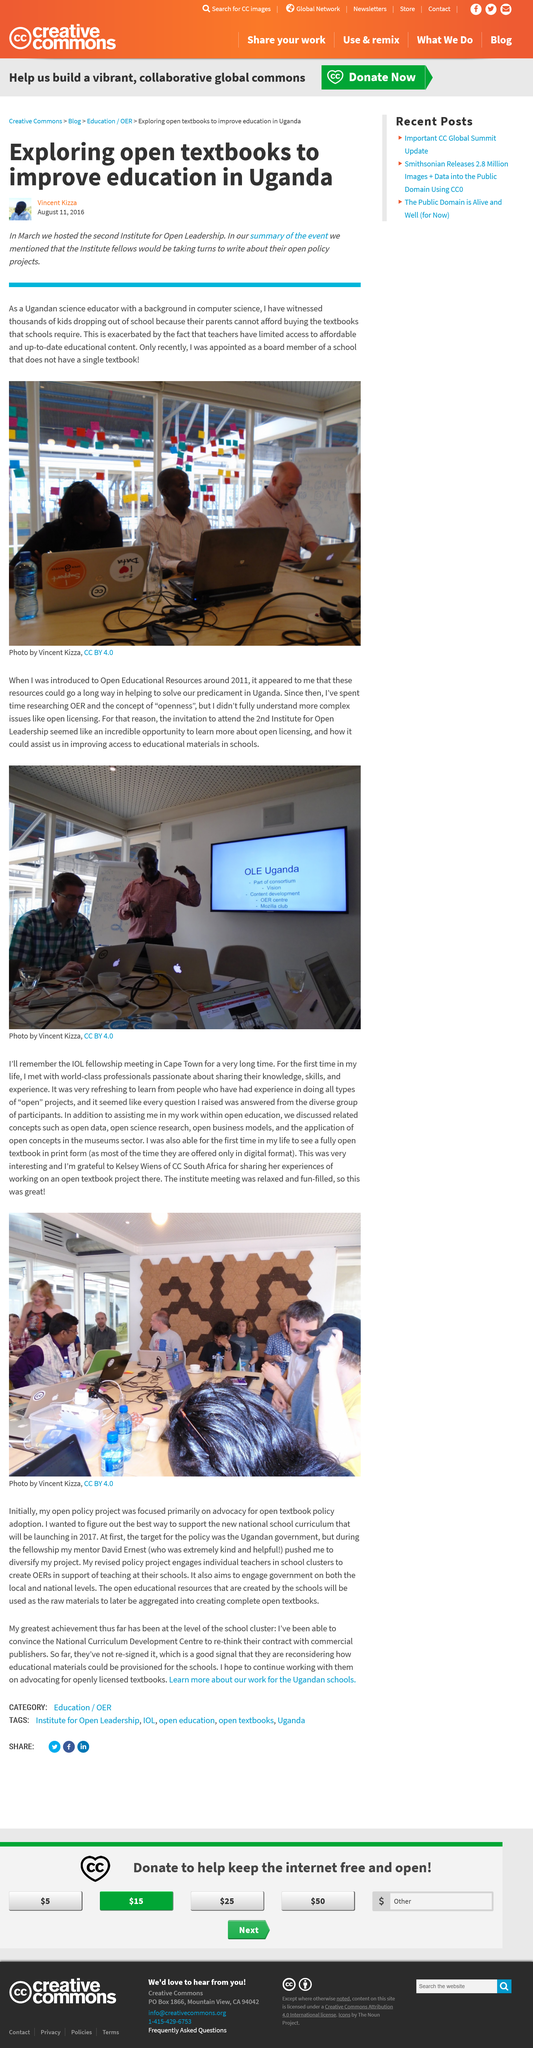Mention a couple of crucial points in this snapshot. The second Institute for Open Leadership was held in March. The school did not have a single textbook. Vincent Kizza wrote the article about textbooks in Uganda. 